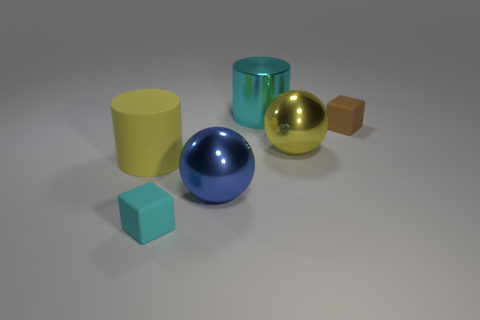Are there any other things that are the same shape as the blue object?
Your answer should be compact. Yes. How many objects are blue shiny objects or cyan blocks?
Give a very brief answer. 2. What is the size of the other cyan thing that is the same shape as the large rubber object?
Make the answer very short. Large. Is there any other thing that is the same size as the brown cube?
Your answer should be compact. Yes. What number of other objects are there of the same color as the big rubber cylinder?
Provide a short and direct response. 1. What number of cylinders are either big cyan things or yellow matte things?
Give a very brief answer. 2. What color is the big cylinder to the right of the tiny object on the left side of the tiny brown object?
Offer a very short reply. Cyan. There is a small cyan rubber thing; what shape is it?
Keep it short and to the point. Cube. There is a cylinder right of the matte cylinder; is its size the same as the big yellow metallic thing?
Your response must be concise. Yes. Is there a brown thing that has the same material as the large blue ball?
Make the answer very short. No. 